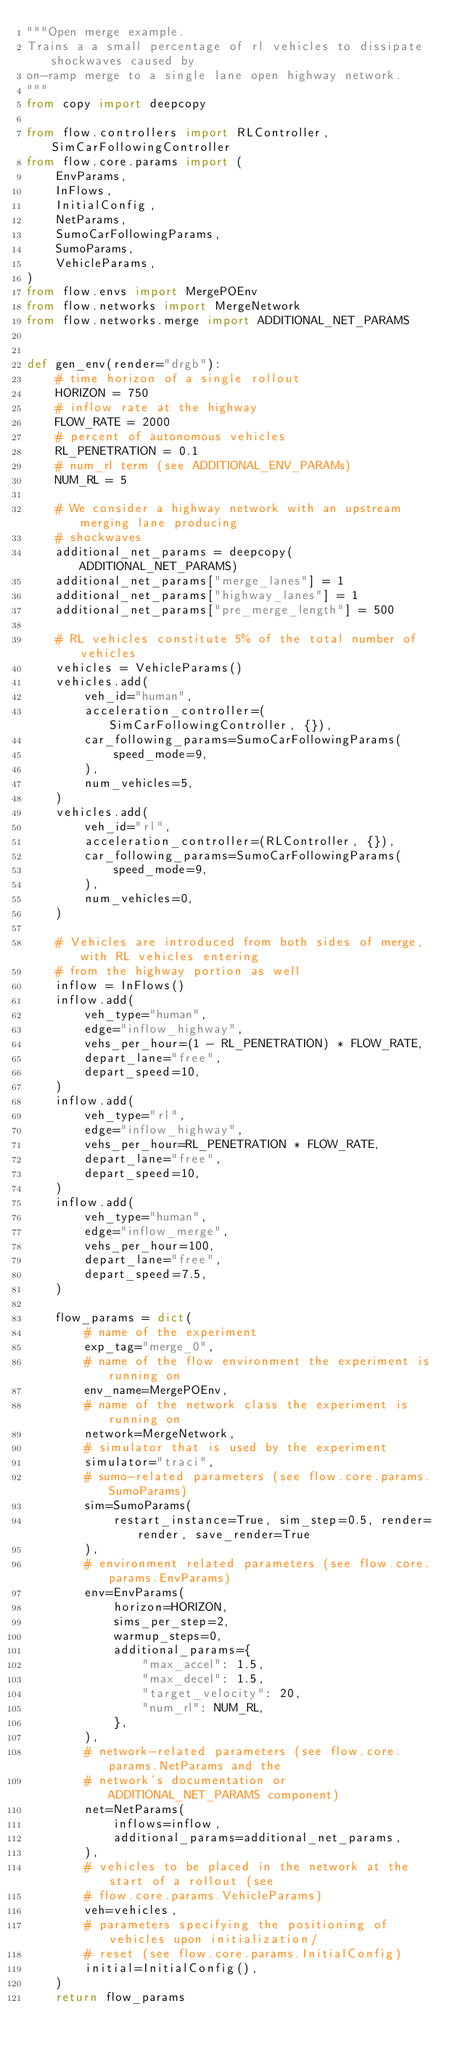<code> <loc_0><loc_0><loc_500><loc_500><_Python_>"""Open merge example.
Trains a a small percentage of rl vehicles to dissipate shockwaves caused by
on-ramp merge to a single lane open highway network.
"""
from copy import deepcopy

from flow.controllers import RLController, SimCarFollowingController
from flow.core.params import (
    EnvParams,
    InFlows,
    InitialConfig,
    NetParams,
    SumoCarFollowingParams,
    SumoParams,
    VehicleParams,
)
from flow.envs import MergePOEnv
from flow.networks import MergeNetwork
from flow.networks.merge import ADDITIONAL_NET_PARAMS


def gen_env(render="drgb"):
    # time horizon of a single rollout
    HORIZON = 750
    # inflow rate at the highway
    FLOW_RATE = 2000
    # percent of autonomous vehicles
    RL_PENETRATION = 0.1
    # num_rl term (see ADDITIONAL_ENV_PARAMs)
    NUM_RL = 5

    # We consider a highway network with an upstream merging lane producing
    # shockwaves
    additional_net_params = deepcopy(ADDITIONAL_NET_PARAMS)
    additional_net_params["merge_lanes"] = 1
    additional_net_params["highway_lanes"] = 1
    additional_net_params["pre_merge_length"] = 500

    # RL vehicles constitute 5% of the total number of vehicles
    vehicles = VehicleParams()
    vehicles.add(
        veh_id="human",
        acceleration_controller=(SimCarFollowingController, {}),
        car_following_params=SumoCarFollowingParams(
            speed_mode=9,
        ),
        num_vehicles=5,
    )
    vehicles.add(
        veh_id="rl",
        acceleration_controller=(RLController, {}),
        car_following_params=SumoCarFollowingParams(
            speed_mode=9,
        ),
        num_vehicles=0,
    )

    # Vehicles are introduced from both sides of merge, with RL vehicles entering
    # from the highway portion as well
    inflow = InFlows()
    inflow.add(
        veh_type="human",
        edge="inflow_highway",
        vehs_per_hour=(1 - RL_PENETRATION) * FLOW_RATE,
        depart_lane="free",
        depart_speed=10,
    )
    inflow.add(
        veh_type="rl",
        edge="inflow_highway",
        vehs_per_hour=RL_PENETRATION * FLOW_RATE,
        depart_lane="free",
        depart_speed=10,
    )
    inflow.add(
        veh_type="human",
        edge="inflow_merge",
        vehs_per_hour=100,
        depart_lane="free",
        depart_speed=7.5,
    )

    flow_params = dict(
        # name of the experiment
        exp_tag="merge_0",
        # name of the flow environment the experiment is running on
        env_name=MergePOEnv,
        # name of the network class the experiment is running on
        network=MergeNetwork,
        # simulator that is used by the experiment
        simulator="traci",
        # sumo-related parameters (see flow.core.params.SumoParams)
        sim=SumoParams(
            restart_instance=True, sim_step=0.5, render=render, save_render=True
        ),
        # environment related parameters (see flow.core.params.EnvParams)
        env=EnvParams(
            horizon=HORIZON,
            sims_per_step=2,
            warmup_steps=0,
            additional_params={
                "max_accel": 1.5,
                "max_decel": 1.5,
                "target_velocity": 20,
                "num_rl": NUM_RL,
            },
        ),
        # network-related parameters (see flow.core.params.NetParams and the
        # network's documentation or ADDITIONAL_NET_PARAMS component)
        net=NetParams(
            inflows=inflow,
            additional_params=additional_net_params,
        ),
        # vehicles to be placed in the network at the start of a rollout (see
        # flow.core.params.VehicleParams)
        veh=vehicles,
        # parameters specifying the positioning of vehicles upon initialization/
        # reset (see flow.core.params.InitialConfig)
        initial=InitialConfig(),
    )
    return flow_params
</code> 